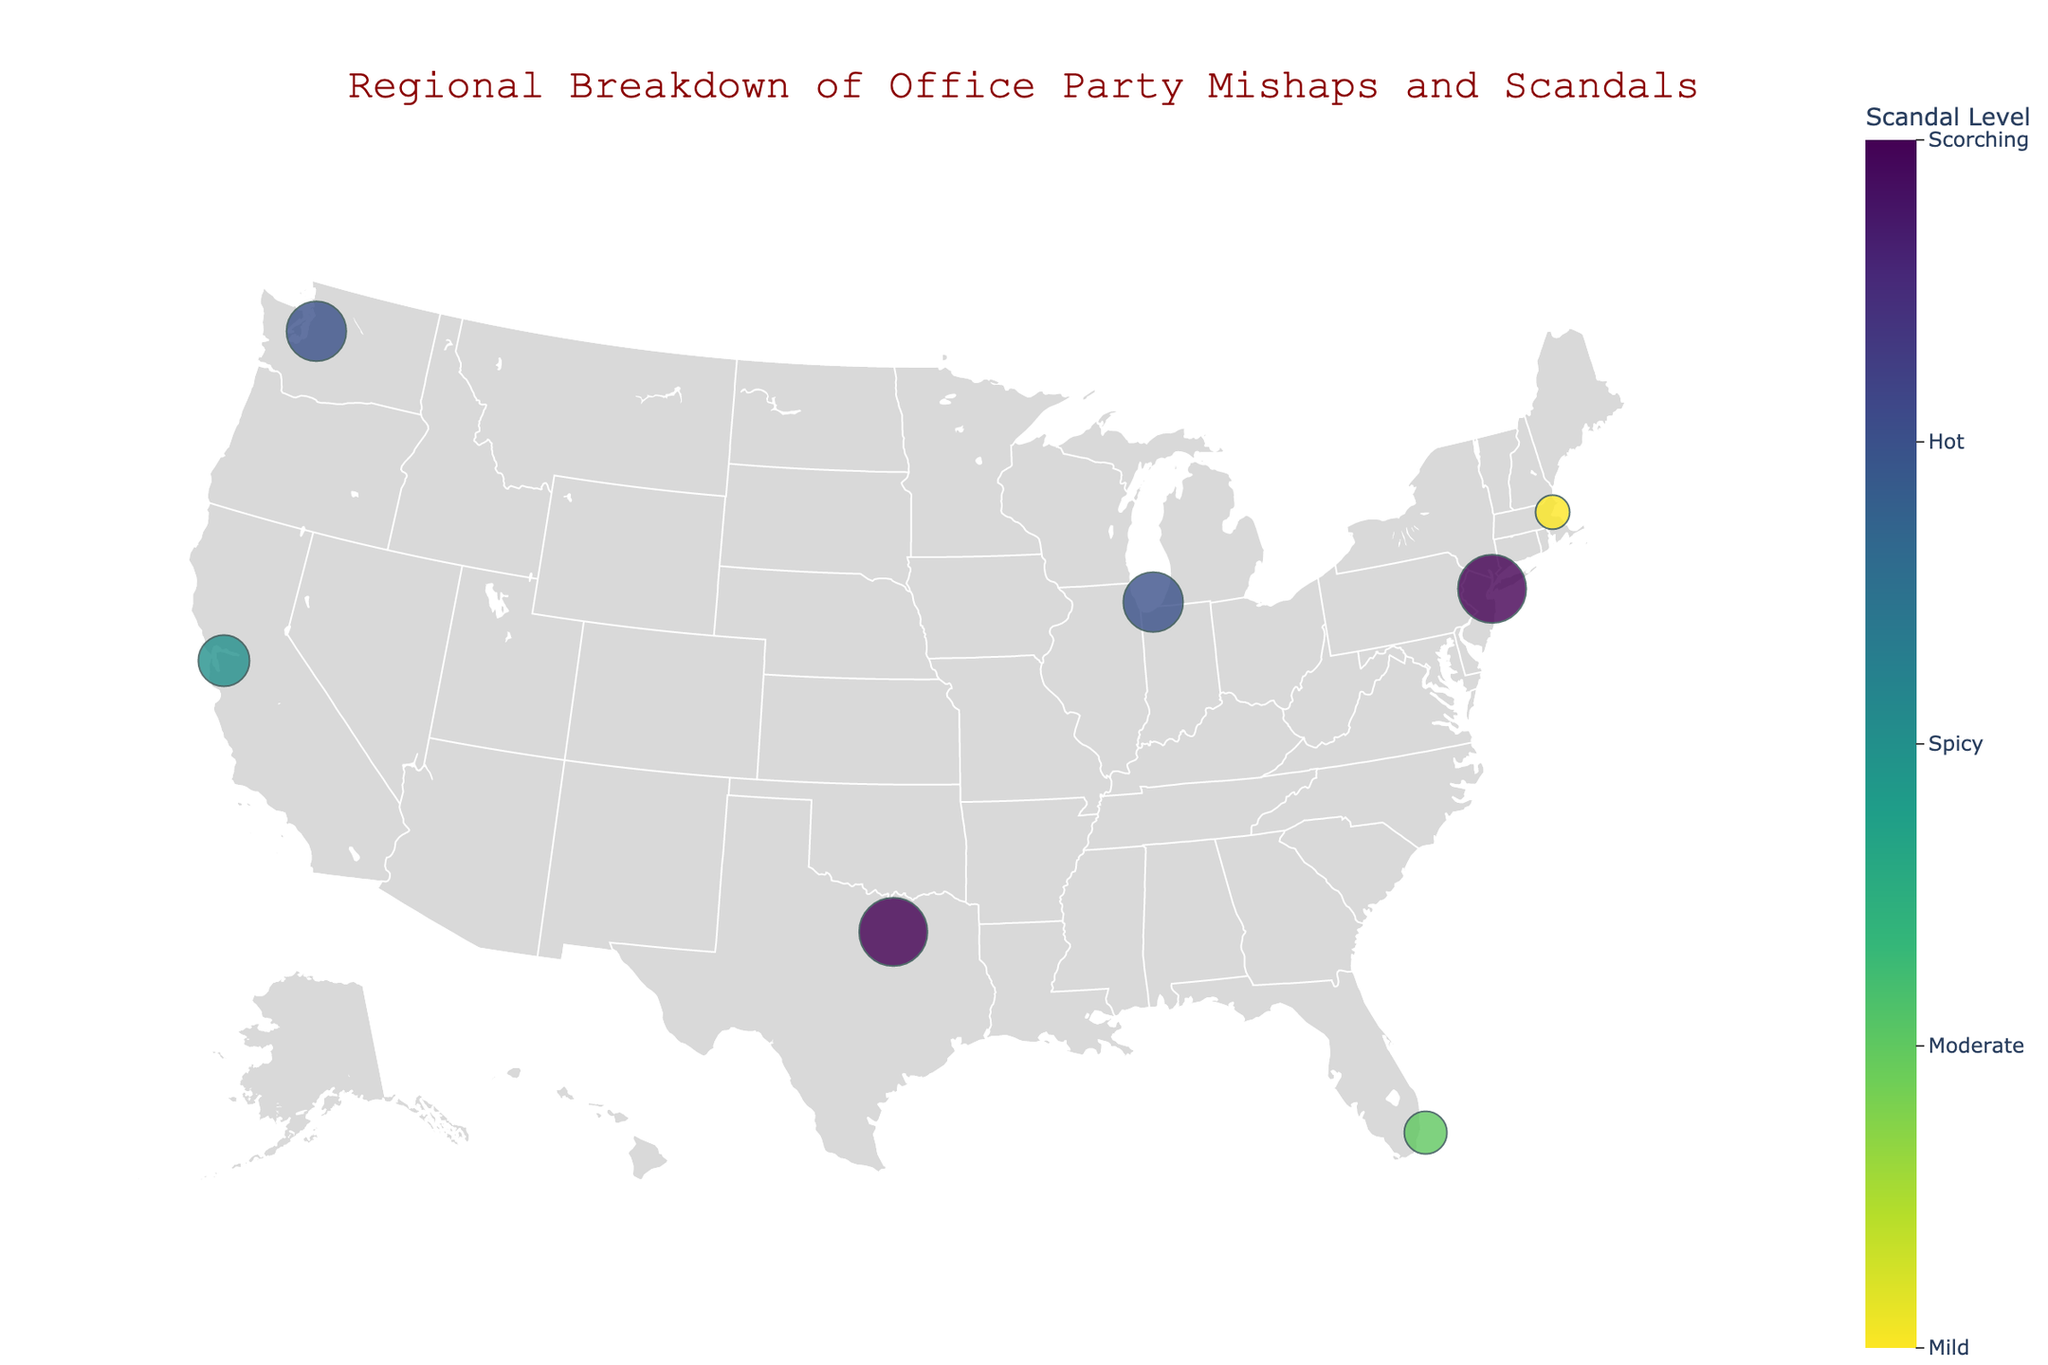What's the title of the figure? The figure has a title in red at the top center.
Answer: Regional Breakdown of Office Party Mishaps and Scandals How many regions have markers on the map? Count the number of distinct markers on the map.
Answer: 7 Which region had the highest scandal level? Identify the marker with the largest size and the text indicating a scandal level of 8.
Answer: New York and Dallas What is the range of scandal levels in the plot? Identifying the minimum and maximum scandal levels indicated by marker sizes.
Answer: 4 to 8 What is the average scandal level for the reported scandalous incidents? Sum all the scandal levels and divide by the number of incidents (8+7+5+7+4+6+8)/7.
Answer: 6.42 Which region had the lowest scandal level? Identify the marker with the smallest size and the text indicating a scandal level of 4.
Answer: Boston Compare the scandal levels of New York and Miami. Which one is higher? New York has a scandal level of 8, and Miami has a scandal level of 5.
Answer: New York Which incident is related to inappropriate copies at the holiday party, and what is its scandal level? Look for the region with "Photocopier Incident" in the details.
Answer: New York, Scandal Level 8 How many regions have scandal levels greater than 6? Count the regions with scandal levels greater than 6. These are indicated by the marker sizes and corresponding text.
Answer: 4 Which region had a viral internal meme incident, and what level was the scandal? The incident "CEO's embarrassing moves become viral internal meme" is found in the text related to Miami with a scandal level of 5.
Answer: Miami, Scandal Level 5 